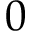<formula> <loc_0><loc_0><loc_500><loc_500>0</formula> 